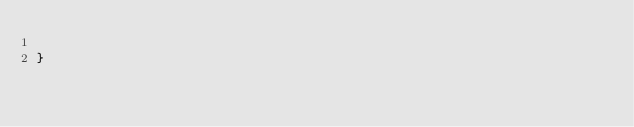Convert code to text. <code><loc_0><loc_0><loc_500><loc_500><_Scala_>
}
</code> 